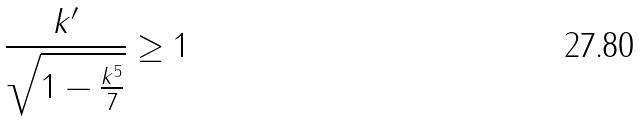<formula> <loc_0><loc_0><loc_500><loc_500>\frac { k ^ { \prime } } { \sqrt { 1 - \frac { k ^ { 5 } } { 7 } } } \geq 1</formula> 